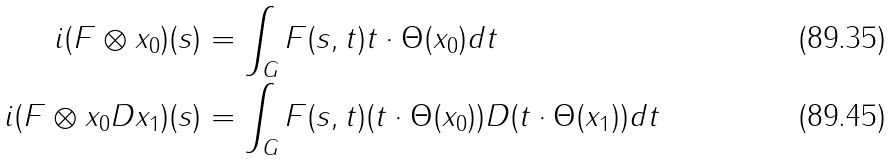<formula> <loc_0><loc_0><loc_500><loc_500>i ( F \otimes x _ { 0 } ) ( s ) & = \int _ { G } F ( s , t ) t \cdot \Theta ( x _ { 0 } ) d t \\ i ( F \otimes x _ { 0 } D x _ { 1 } ) ( s ) & = \int _ { G } F ( s , t ) ( t \cdot \Theta ( x _ { 0 } ) ) D ( t \cdot \Theta ( x _ { 1 } ) ) d t</formula> 